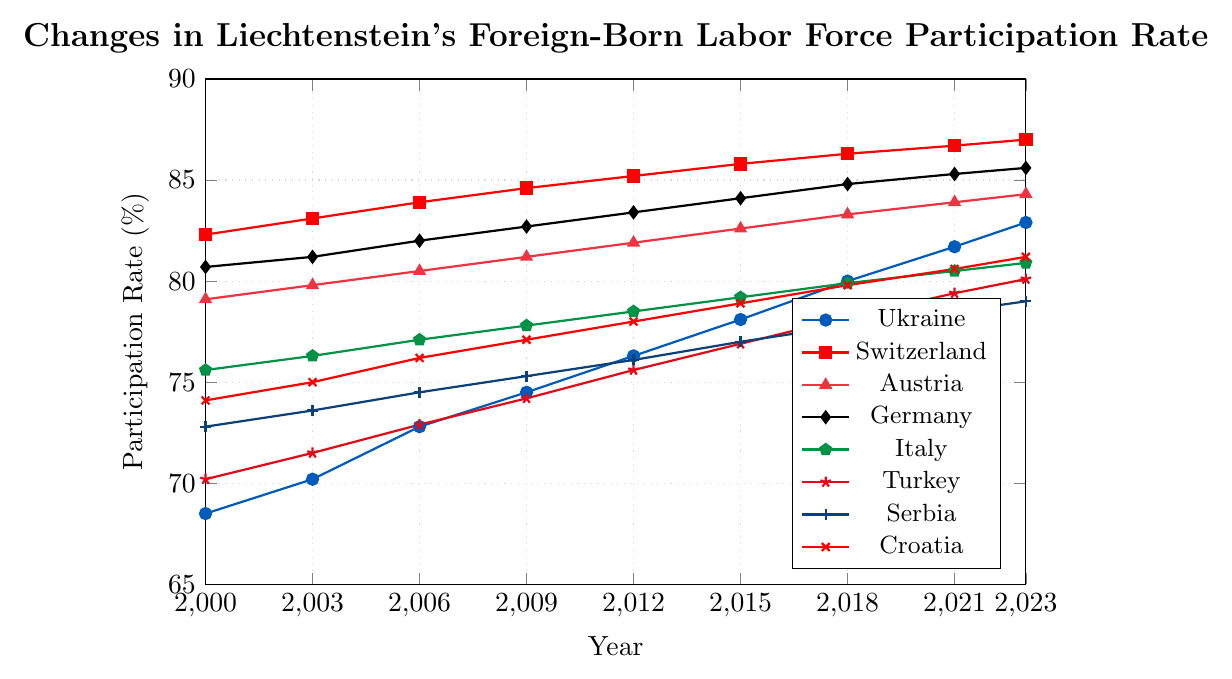What was the labor force participation rate for people born in Ukraine in the year 2000? Locate the line for Ukraine in the chart. Find the value at the year 2000 on this line.
Answer: 68.5% Which country had the highest labor force participation rate in 2023? Compare the participation rates for all countries in the year 2023. Identify the highest value.
Answer: Switzerland By how much did the labor force participation rate for people from Germany increase from 2000 to 2023? Locate the line for Germany. Subtract the value at 2000 from the value at 2023. \(85.6 - 80.7 = 4.9\)
Answer: 4.9% Which country had the lowest participation rate in the year 2000? Compare the participation rates for all countries in the year 2000. Identify the lowest value.
Answer: Ukraine What is the average labor force participation rate for Italy from 2000 to 2023? Sum the data points for Italy and divide by the number of years (9). \((75.6 + 76.3 + 77.1 + 77.8 + 78.5 + 79.2 + 79.9 + 80.5 + 80.9) / 9 = 78.4\)
Answer: 78.4% Which country had a consistent increase in labor force participation rate every recorded year? Examine each country's line, checking if there are no decreases between any consecutive years. Identify the country with no decreases.
Answer: Croatia By how much did the participation rate for people born in Turkey change from 2003 to 2018? Subtract the participation rate for Turkey in 2003 from that in 2018. \(78.2 - 71.5 = 6.7\)
Answer: 6.7% Which two countries had the closest labor force participation rates in 2021? Compare the participation rates for all countries in 2021. Identify the two closest values.
Answer: Italy and Croatia In which year did people born in Austria first surpass an 80% labor force participation rate? Locate the line for Austria and find the earliest year where the value is above 80%.
Answer: 2003 